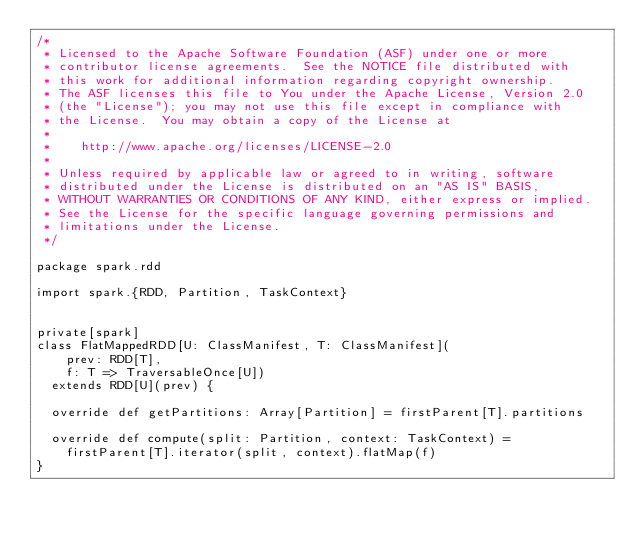<code> <loc_0><loc_0><loc_500><loc_500><_Scala_>/*
 * Licensed to the Apache Software Foundation (ASF) under one or more
 * contributor license agreements.  See the NOTICE file distributed with
 * this work for additional information regarding copyright ownership.
 * The ASF licenses this file to You under the Apache License, Version 2.0
 * (the "License"); you may not use this file except in compliance with
 * the License.  You may obtain a copy of the License at
 *
 *    http://www.apache.org/licenses/LICENSE-2.0
 *
 * Unless required by applicable law or agreed to in writing, software
 * distributed under the License is distributed on an "AS IS" BASIS,
 * WITHOUT WARRANTIES OR CONDITIONS OF ANY KIND, either express or implied.
 * See the License for the specific language governing permissions and
 * limitations under the License.
 */

package spark.rdd

import spark.{RDD, Partition, TaskContext}


private[spark]
class FlatMappedRDD[U: ClassManifest, T: ClassManifest](
    prev: RDD[T],
    f: T => TraversableOnce[U])
  extends RDD[U](prev) {

  override def getPartitions: Array[Partition] = firstParent[T].partitions

  override def compute(split: Partition, context: TaskContext) =
    firstParent[T].iterator(split, context).flatMap(f)
}
</code> 